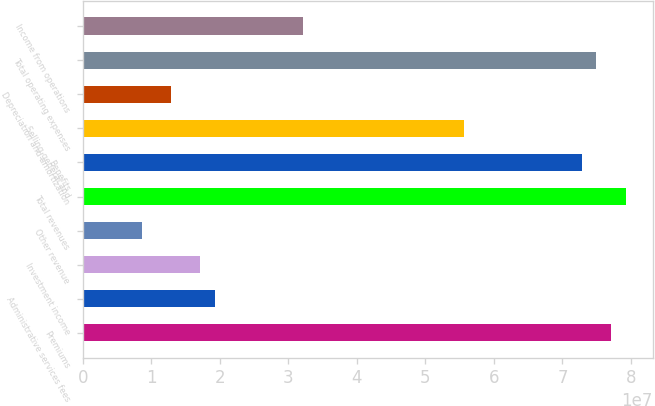Convert chart to OTSL. <chart><loc_0><loc_0><loc_500><loc_500><bar_chart><fcel>Premiums<fcel>Administrative services fees<fcel>Investment income<fcel>Other revenue<fcel>Total revenues<fcel>Benefits<fcel>Selling general and<fcel>Depreciation and amortization<fcel>Total operating expenses<fcel>Income from operations<nl><fcel>7.70995e+07<fcel>1.92749e+07<fcel>1.71332e+07<fcel>8.56662e+06<fcel>7.92412e+07<fcel>7.28162e+07<fcel>5.5683e+07<fcel>1.28499e+07<fcel>7.49579e+07<fcel>3.21248e+07<nl></chart> 